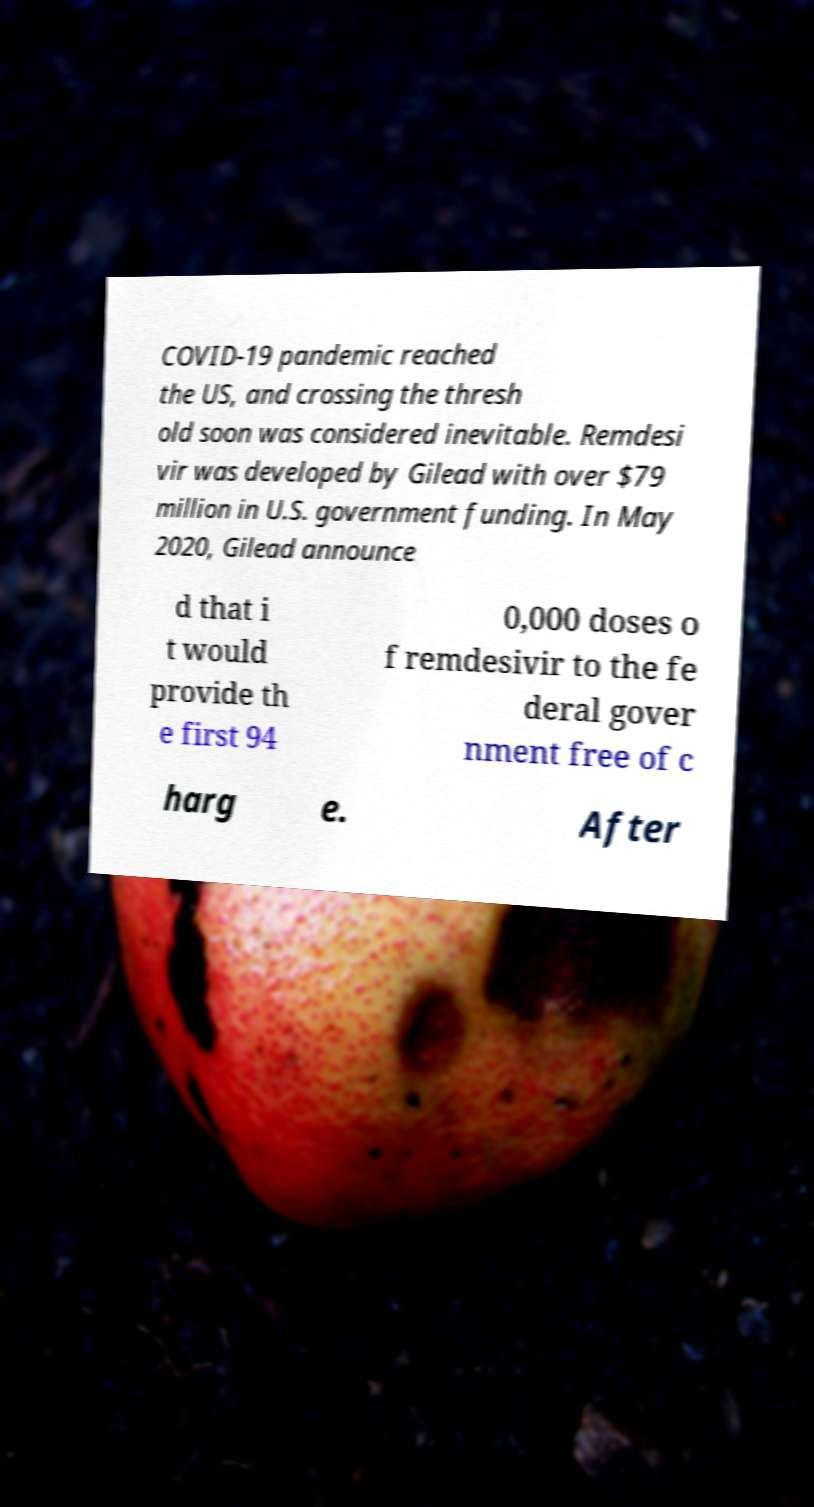Could you extract and type out the text from this image? COVID-19 pandemic reached the US, and crossing the thresh old soon was considered inevitable. Remdesi vir was developed by Gilead with over $79 million in U.S. government funding. In May 2020, Gilead announce d that i t would provide th e first 94 0,000 doses o f remdesivir to the fe deral gover nment free of c harg e. After 